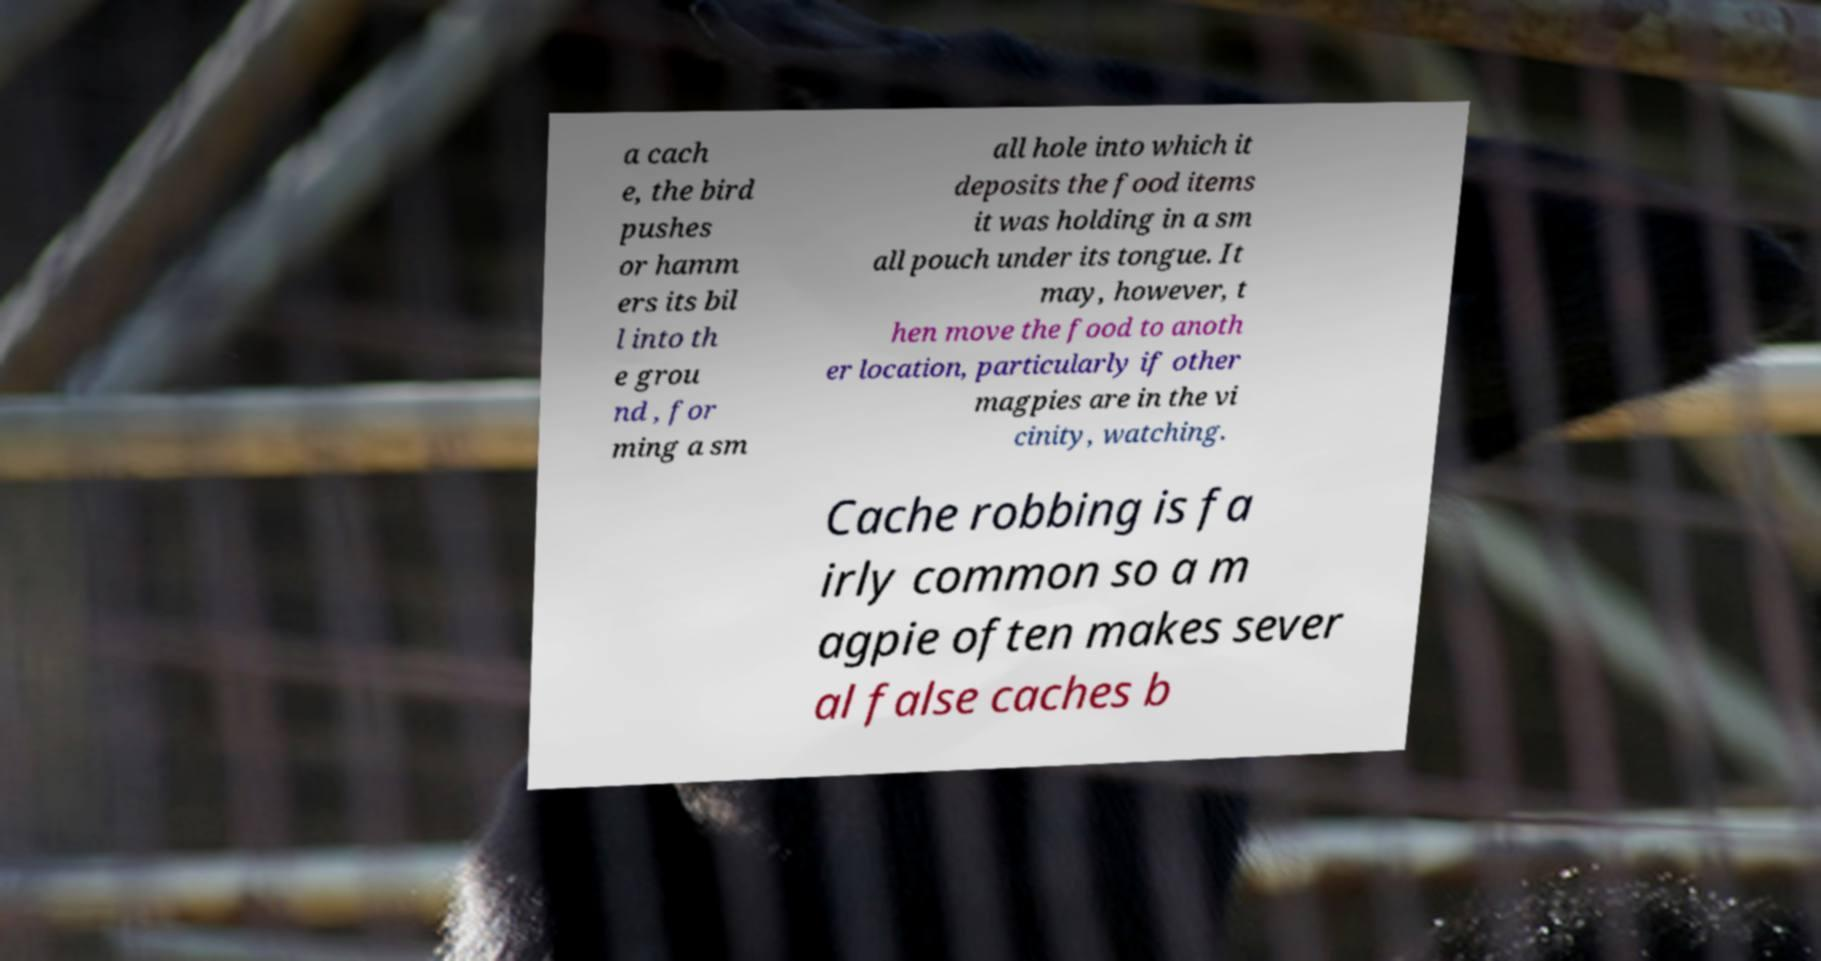Can you accurately transcribe the text from the provided image for me? a cach e, the bird pushes or hamm ers its bil l into th e grou nd , for ming a sm all hole into which it deposits the food items it was holding in a sm all pouch under its tongue. It may, however, t hen move the food to anoth er location, particularly if other magpies are in the vi cinity, watching. Cache robbing is fa irly common so a m agpie often makes sever al false caches b 